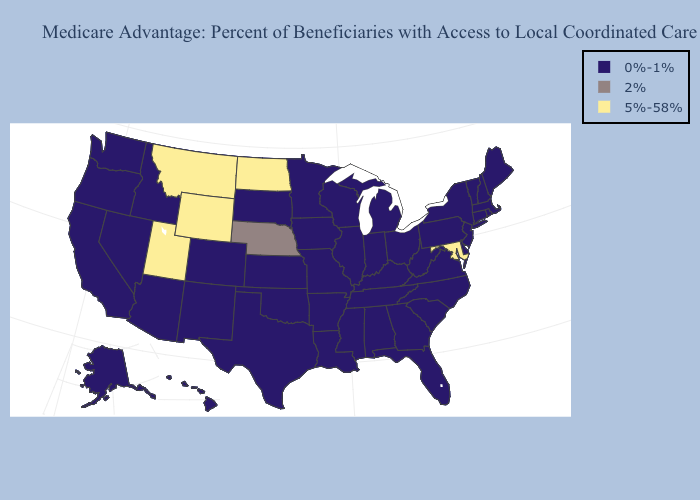What is the value of Pennsylvania?
Concise answer only. 0%-1%. What is the highest value in the MidWest ?
Concise answer only. 5%-58%. Does Wisconsin have the same value as New Jersey?
Give a very brief answer. Yes. Does Wyoming have the lowest value in the USA?
Quick response, please. No. Does the first symbol in the legend represent the smallest category?
Write a very short answer. Yes. Among the states that border Nevada , does Oregon have the highest value?
Short answer required. No. What is the value of Wisconsin?
Keep it brief. 0%-1%. Is the legend a continuous bar?
Answer briefly. No. Is the legend a continuous bar?
Give a very brief answer. No. Which states have the lowest value in the USA?
Give a very brief answer. Alabama, Alaska, Arizona, Arkansas, California, Colorado, Connecticut, Delaware, Florida, Georgia, Hawaii, Idaho, Illinois, Indiana, Iowa, Kansas, Kentucky, Louisiana, Maine, Massachusetts, Michigan, Minnesota, Mississippi, Missouri, Nevada, New Hampshire, New Jersey, New Mexico, New York, North Carolina, Ohio, Oklahoma, Oregon, Pennsylvania, Rhode Island, South Carolina, South Dakota, Tennessee, Texas, Vermont, Virginia, Washington, West Virginia, Wisconsin. What is the lowest value in the USA?
Give a very brief answer. 0%-1%. What is the highest value in the Northeast ?
Concise answer only. 0%-1%. 